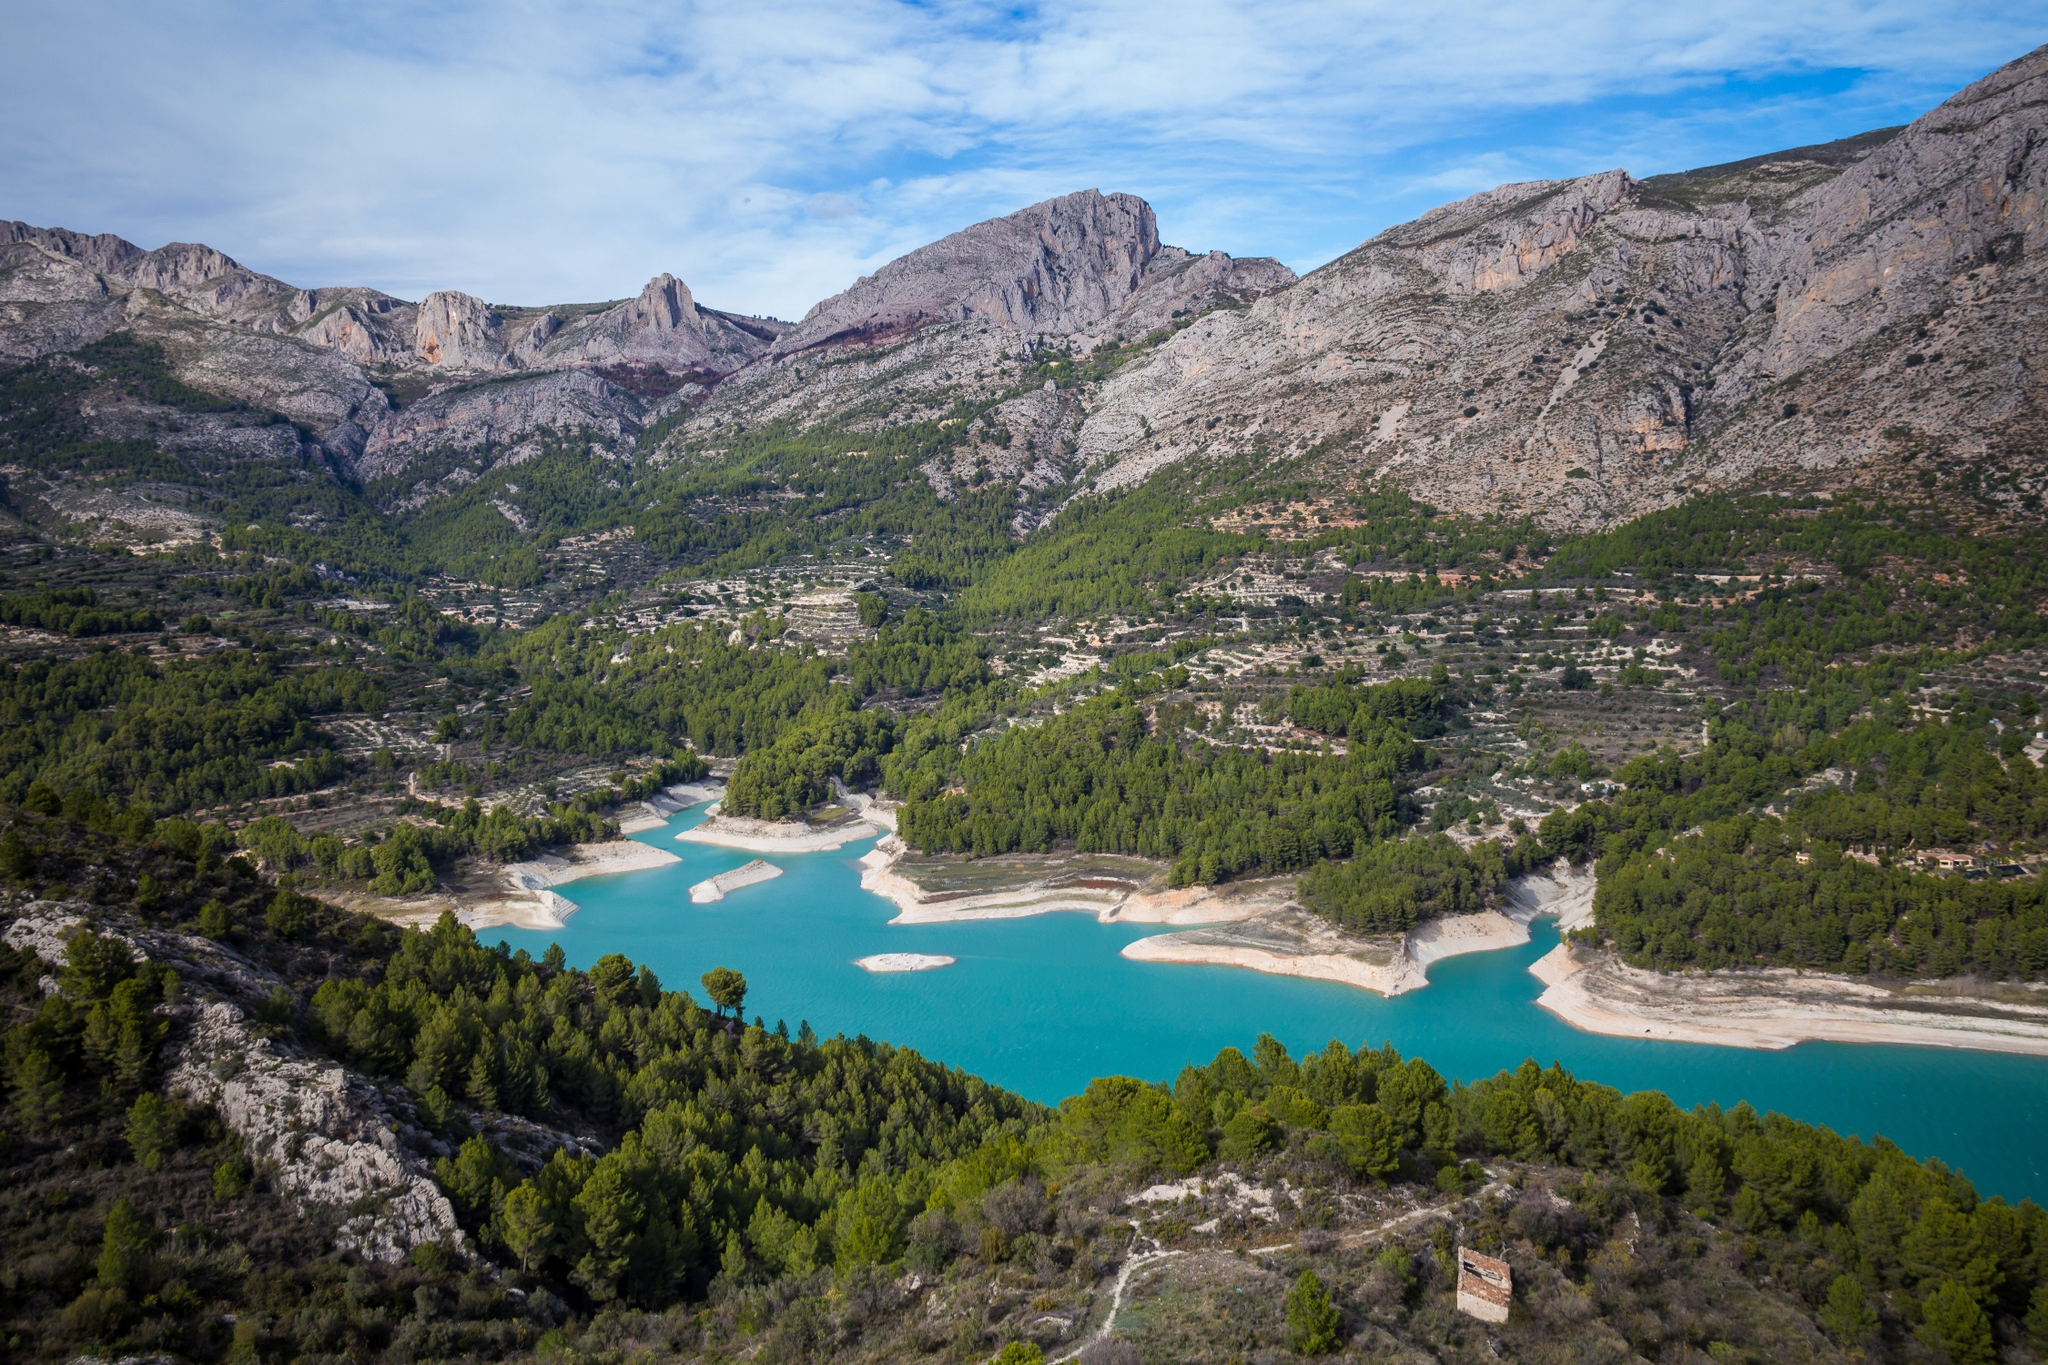Can you discuss the ecological significance of this area? The Guadalest Reservoir plays a critical ecological role in the region. It not only serves as a vital water source for irrigation and local consumption but also supports a diverse ecosystem. The surrounding forests and mountainous terrain act as a natural sanctuary for wildlife, including several endangered species. The reservoir's clean waters contribute to maintaining the health of aquatic ecosystems, thereby supporting a variety of fish and amphibian species. This balance enhances the biological diversity of the area, making it an important site for conservation efforts. 